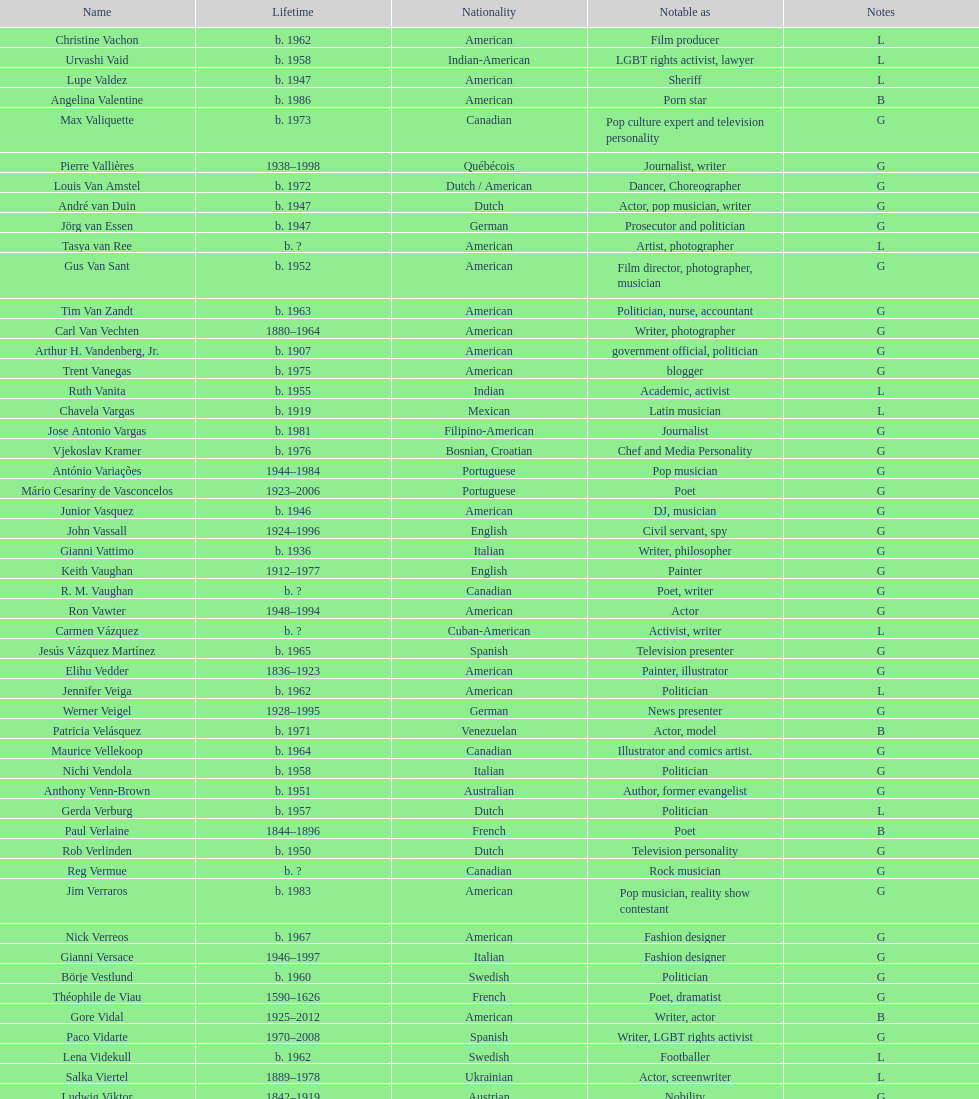Which ethnicity has the highest population associated with it? American. 